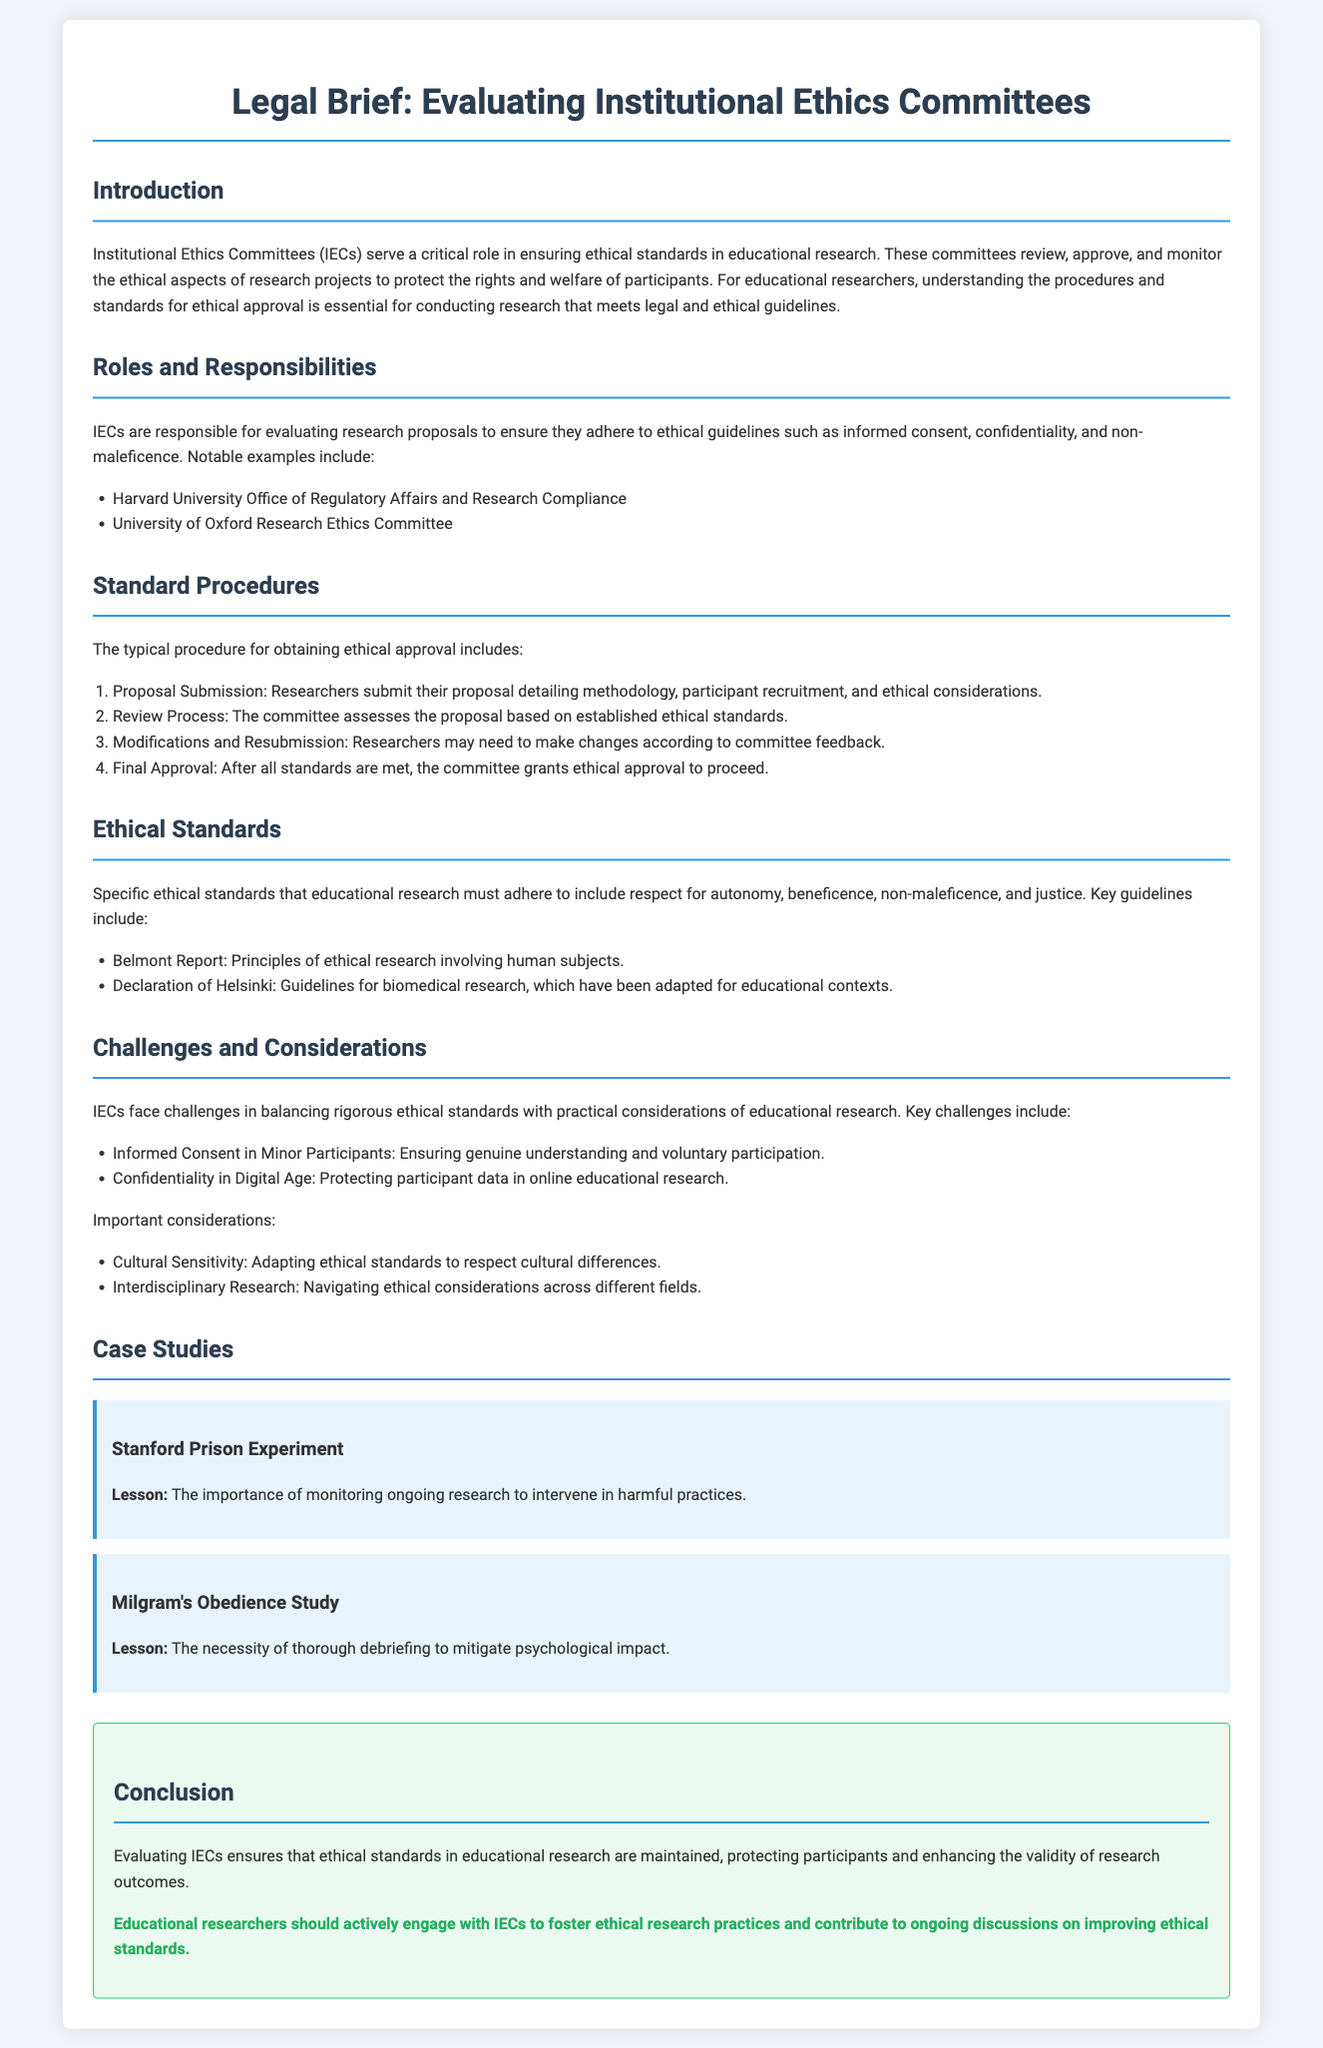What is the main role of Institutional Ethics Committees? The main role of IECs is to ensure ethical standards in educational research by reviewing, approving, and monitoring research projects.
Answer: Ensuring ethical standards Which document outlines ethical research principles involving human subjects? The Belmont Report outlines the principles of ethical research involving human subjects.
Answer: Belmont Report What is the first step in the standard procedure for obtaining ethical approval? The first step is Proposal Submission, where researchers submit their proposal detailing methodology and ethical considerations.
Answer: Proposal Submission What challenge do IECs face regarding minor participants? IECs face challenges ensuring genuine understanding and voluntary participation from minor participants.
Answer: Informed Consent How many case studies are presented in the document? The document presents two case studies.
Answer: Two What is a key ethical standard mentioned in the brief? A key ethical standard mentioned is respect for autonomy.
Answer: Respect for autonomy Which committee is mentioned as an example of an IEC? Harvard University Office of Regulatory Affairs and Research Compliance is mentioned as an example.
Answer: Harvard University Office of Regulatory Affairs and Research Compliance What significant lesson comes from the Stanford Prison Experiment? The lesson is the importance of monitoring ongoing research to intervene in harmful practices.
Answer: Monitoring ongoing research What is the call to action for educational researchers in the conclusion? The call to action encourages educational researchers to engage with IECs to foster ethical research practices.
Answer: Engage with IECs 